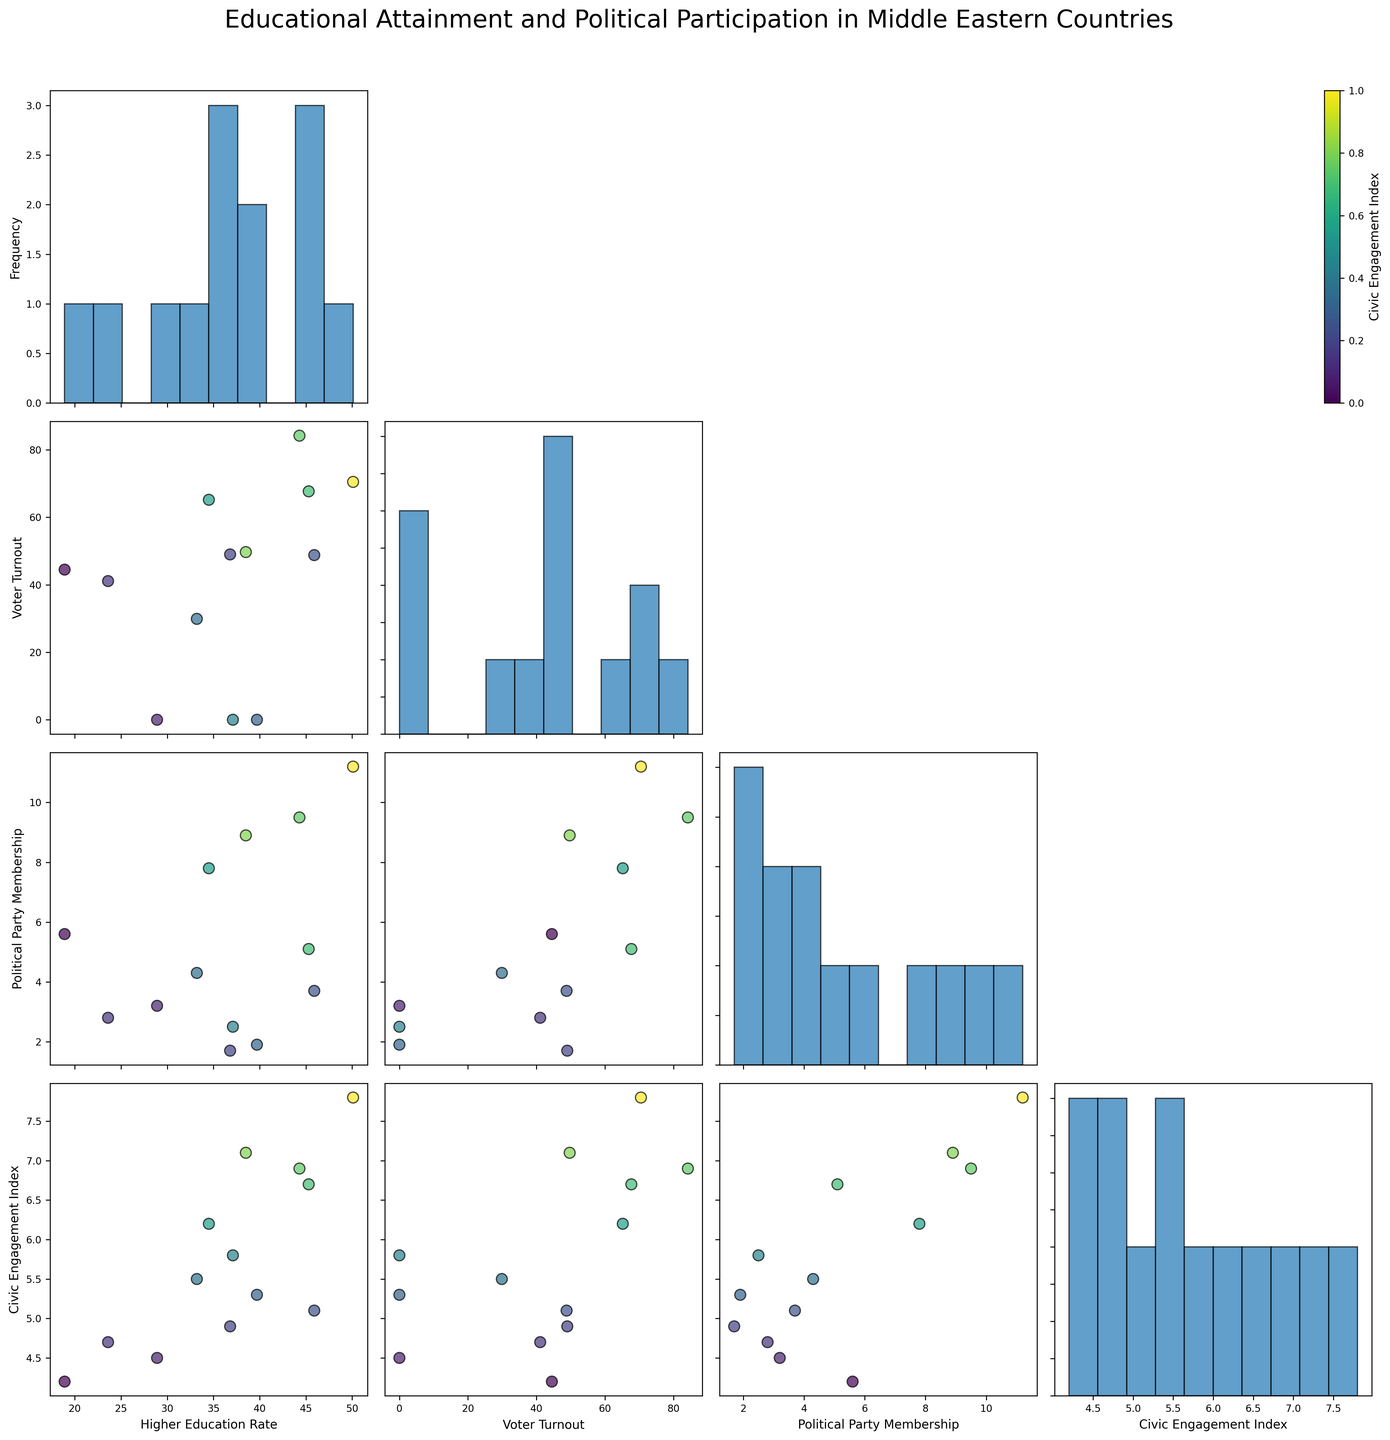what is the title of the figure? The title of the figure is displayed at the top of the plot. You can read it directly from there.
Answer: Educational Attainment and Political Participation in Middle Eastern Countries Based on the scatterplot matrix, which country has the highest rate of higher education? The highest rate of higher education can be found by looking at the scatter plot labeled "Higher Education Rate" on either axis and identifying the maximum value.
Answer: Israel How many variables are plotted in the scatterplot matrix? By counting the unique variables along the axis of the scatterplot matrix, you can determine the total number of variables plotted.
Answer: Four Which country has the lowest higher education rate and what is it? By checking the scatter plot labeled "Higher Education Rate" and finding the minimum value, you can determine the country with the lowest rate.
Answer: Iraq Is there a notable correlation between Higher Education Rate and Civic Engagement Index? By examining the scatter plot matrix where "Higher Education Rate" is on one axis and "Civic Engagement Index" is on the other, you can see the trend of the plotted points to determine if there is a correlation (positive, negative, or none).
Answer: Yes, generally positive Which two countries have a very high Voter Turnout, and how do they compare in Political Party Membership? Look at the scatter plot section for "Voter Turnout" and identify two countries with high values. Then compare these two values in the Political Party Membership variable.
Answer: Israel and Turkey; Israel has higher Political Party Membership Between Saudi Arabia and Egypt, which country shows higher Civic Engagement Index? By locating the data points for Saudi Arabia and Egypt in the scatter plot for Civic Engagement Index, one can compare their respective values.
Answer: Saudi Arabia How does Political Party Membership correlate with Voter Turnout? In the scatterplot matrix, locate the intersection where Political Party Membership is on one axis and Voter Turnout is on the other. Examine the pattern of the points to infer the correlation.
Answer: Weak or no correlation What is the range of Voter Turnout across the countries plotted? Identify the minimum and maximum Voter Turnout values from the scatter plot labeled "Voter Turnout".
Answer: 0 to 84.2 In the scatter plots, where higher education is on the x-axis and civic engagement is on the y-axis, which country stands out positively and why? Locate the plots where the x-axis is labeled "Higher Education Rate" and the y-axis is "Civic Engagement Index". Identify the country with a notable high value in Civic Engagement.
Answer: Israel, due to high Civic Engagement Index 